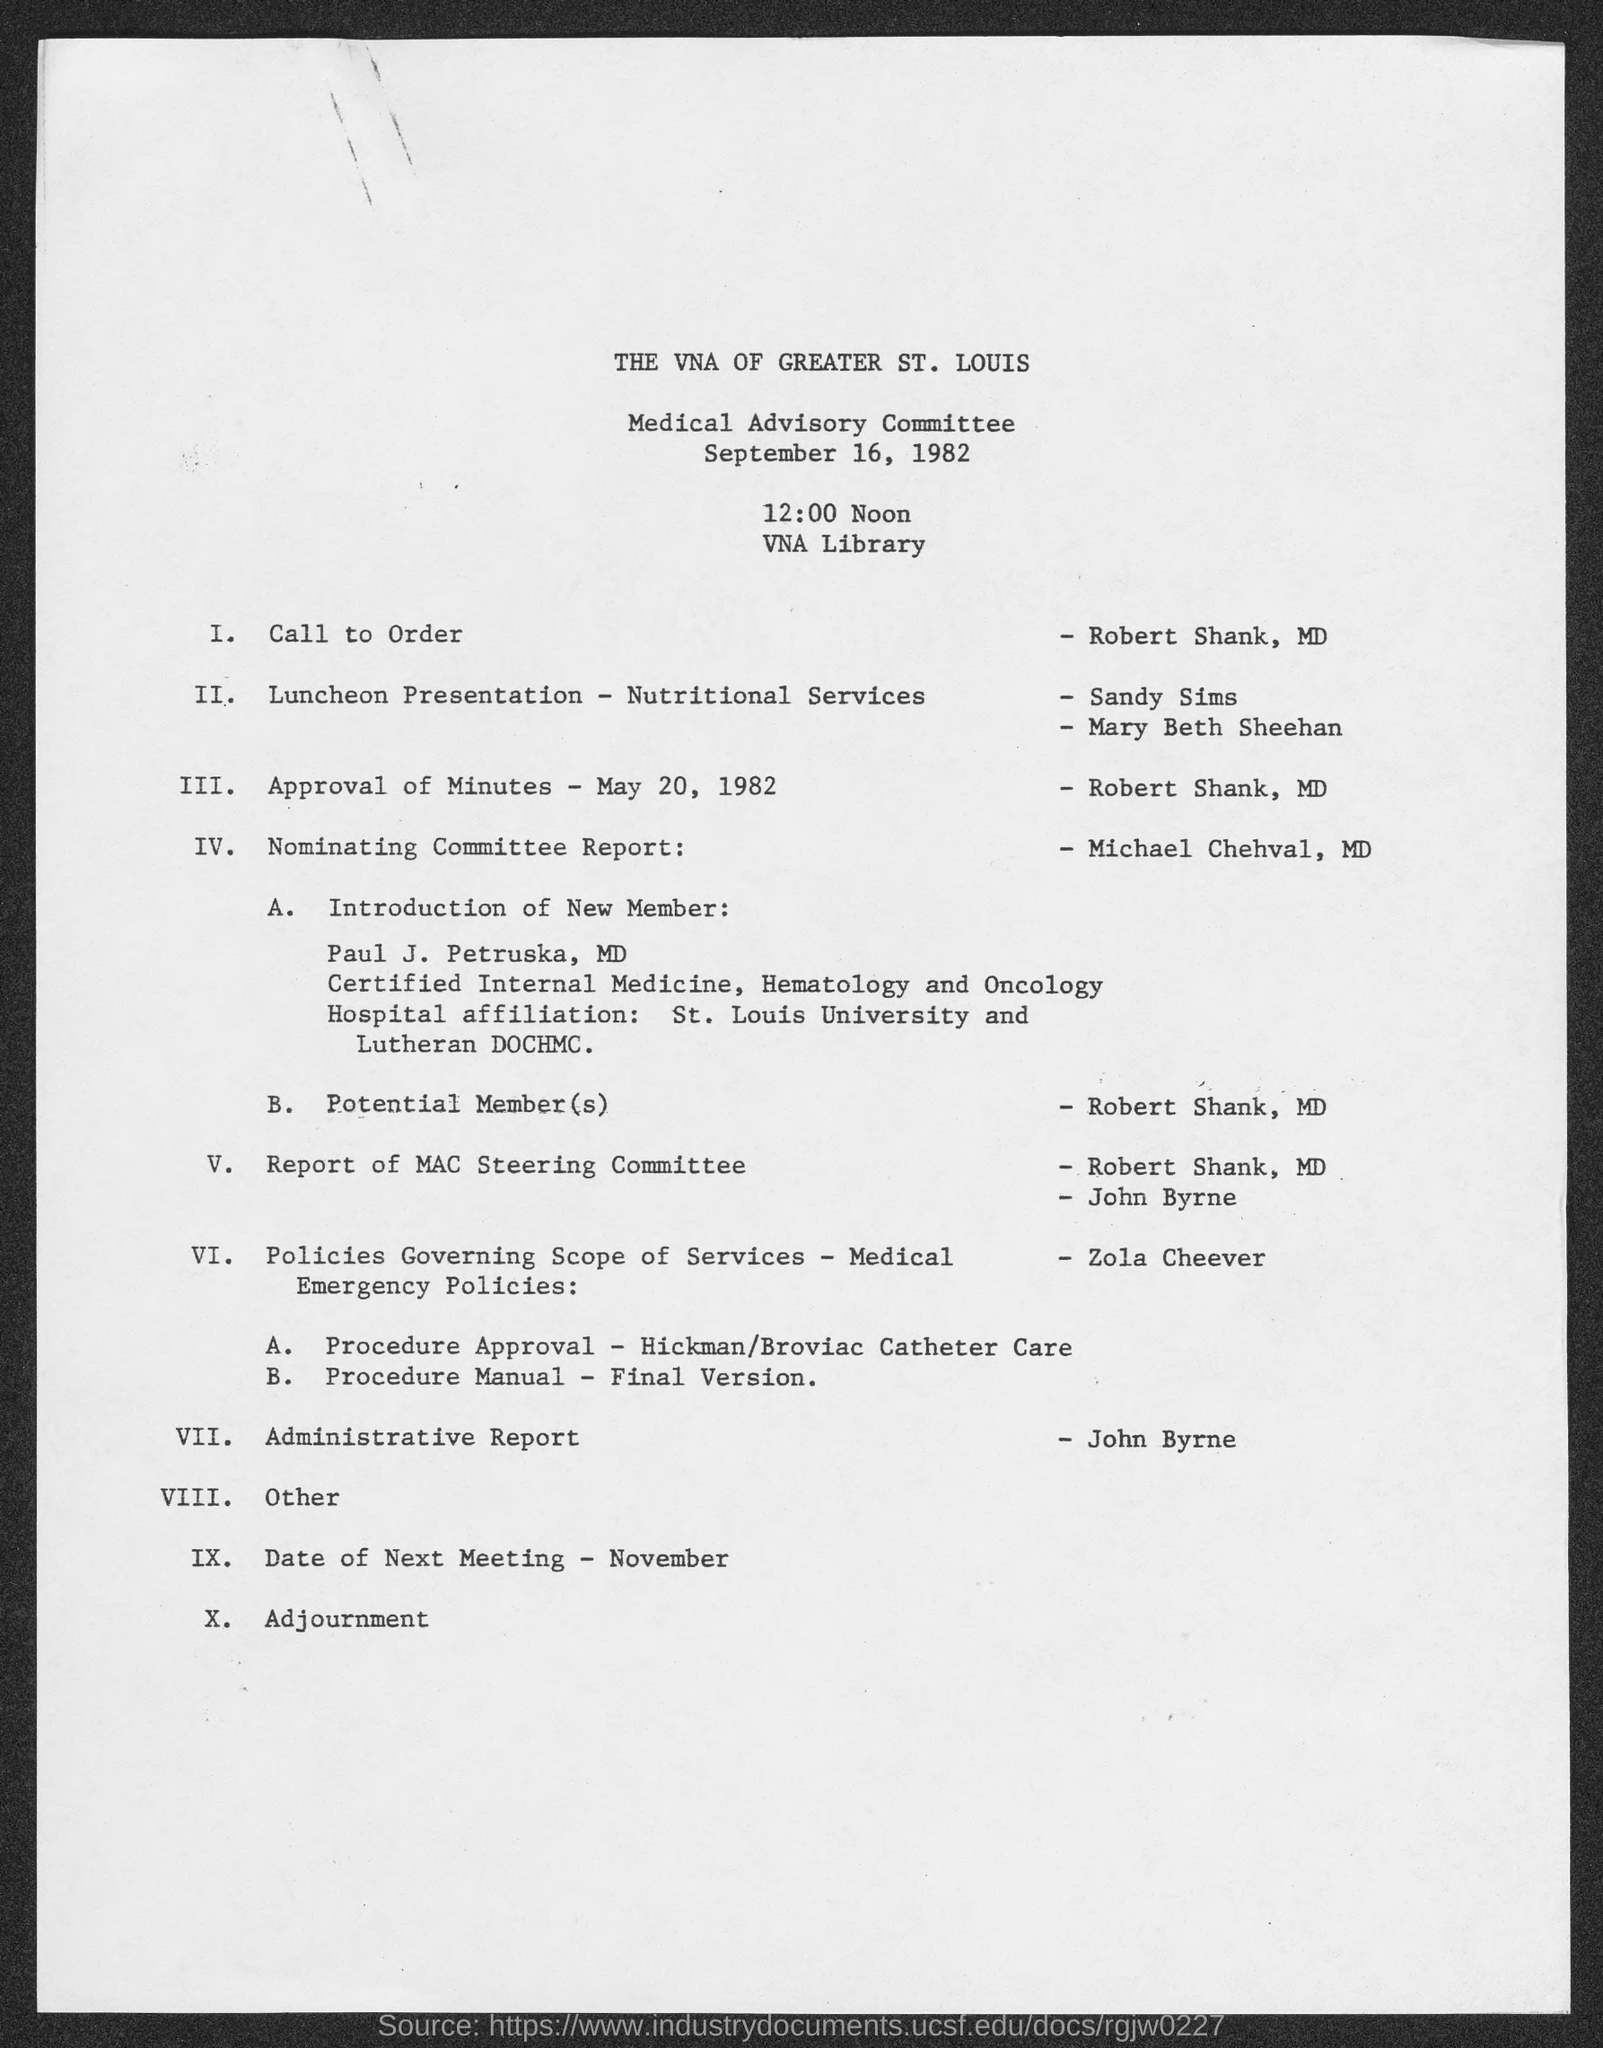Indicate a few pertinent items in this graphic. The topic of the nominating committee report is handled by Michael Chehval. The date of the Medical Advisory Committee is September 16, 1982. The Call to Order has been issued by Robert Shank, MD. The venue of the Committee is the VNA Library. 